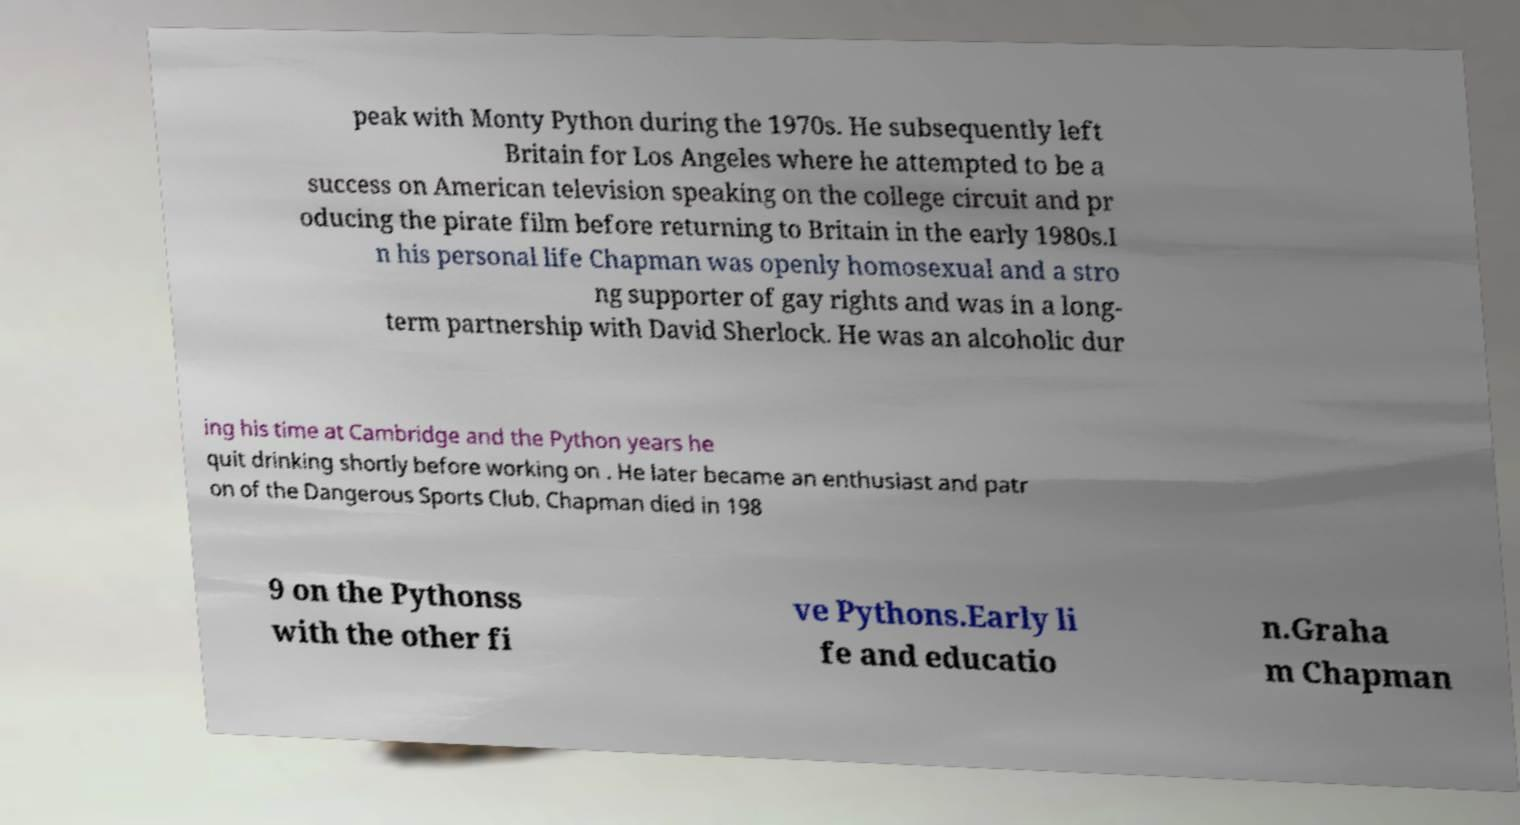Please read and relay the text visible in this image. What does it say? peak with Monty Python during the 1970s. He subsequently left Britain for Los Angeles where he attempted to be a success on American television speaking on the college circuit and pr oducing the pirate film before returning to Britain in the early 1980s.I n his personal life Chapman was openly homosexual and a stro ng supporter of gay rights and was in a long- term partnership with David Sherlock. He was an alcoholic dur ing his time at Cambridge and the Python years he quit drinking shortly before working on . He later became an enthusiast and patr on of the Dangerous Sports Club. Chapman died in 198 9 on the Pythonss with the other fi ve Pythons.Early li fe and educatio n.Graha m Chapman 